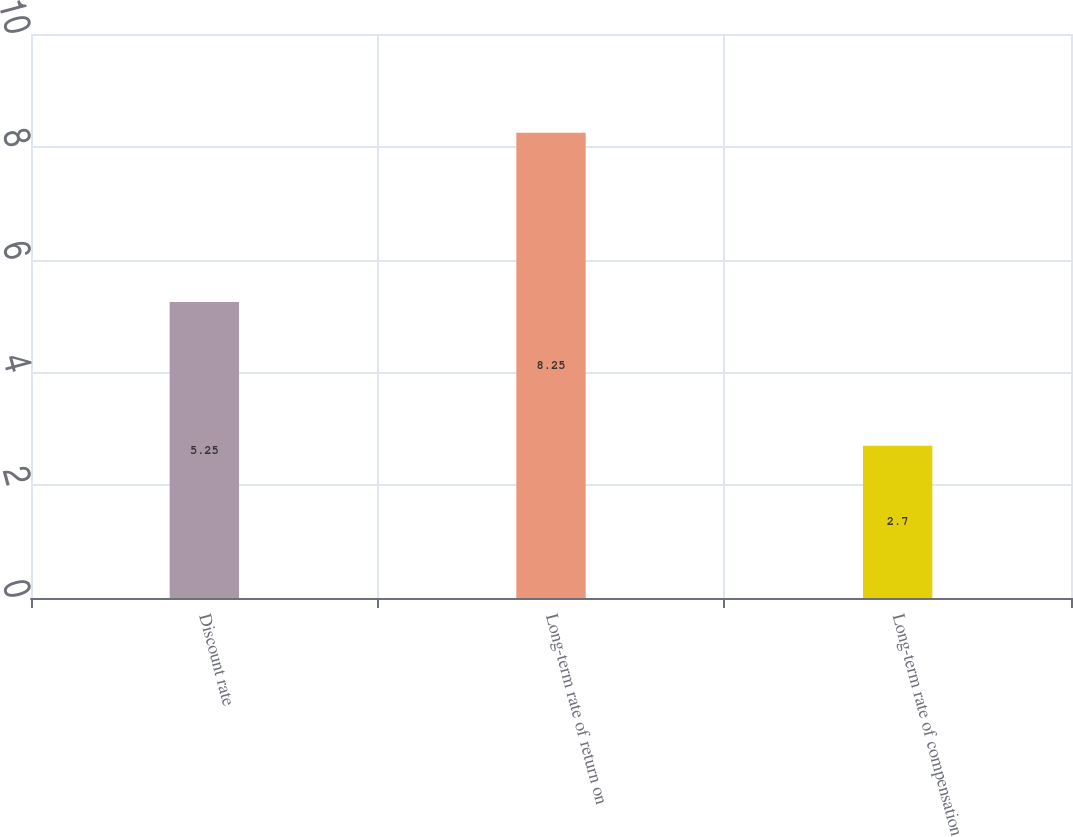Convert chart to OTSL. <chart><loc_0><loc_0><loc_500><loc_500><bar_chart><fcel>Discount rate<fcel>Long-term rate of return on<fcel>Long-term rate of compensation<nl><fcel>5.25<fcel>8.25<fcel>2.7<nl></chart> 